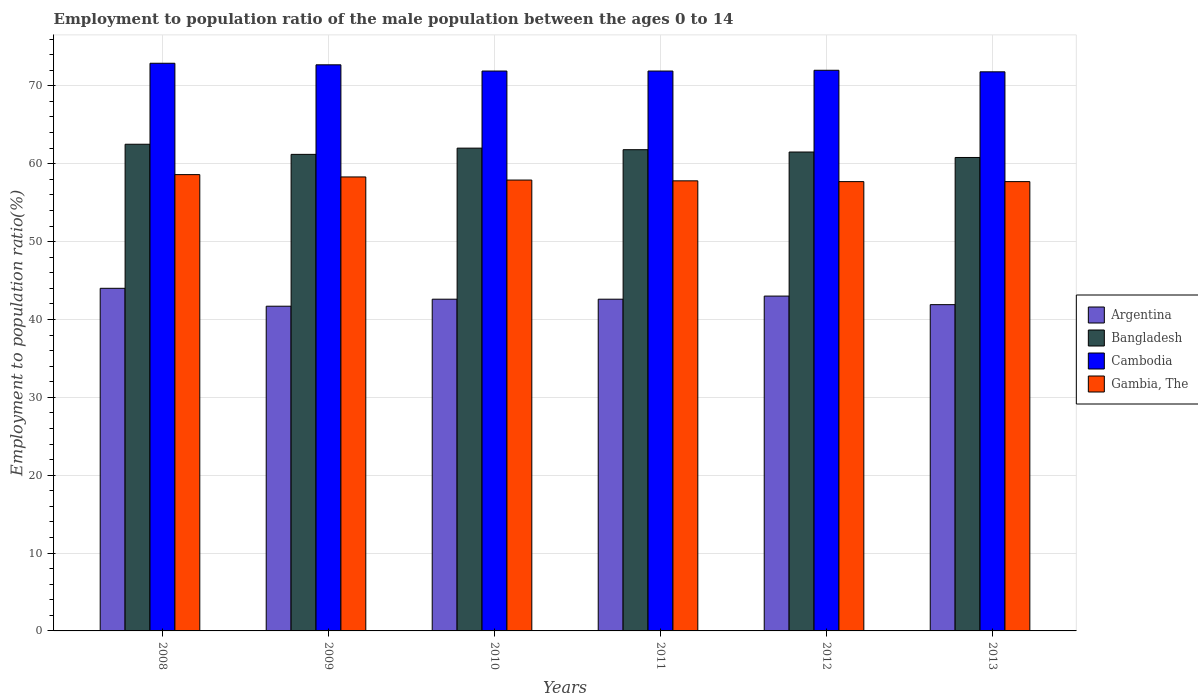How many different coloured bars are there?
Your response must be concise. 4. Are the number of bars on each tick of the X-axis equal?
Offer a terse response. Yes. What is the employment to population ratio in Gambia, The in 2012?
Your answer should be very brief. 57.7. Across all years, what is the maximum employment to population ratio in Bangladesh?
Make the answer very short. 62.5. Across all years, what is the minimum employment to population ratio in Argentina?
Keep it short and to the point. 41.7. What is the total employment to population ratio in Cambodia in the graph?
Make the answer very short. 433.2. What is the difference between the employment to population ratio in Gambia, The in 2008 and that in 2013?
Your answer should be very brief. 0.9. What is the difference between the employment to population ratio in Gambia, The in 2012 and the employment to population ratio in Cambodia in 2013?
Your answer should be very brief. -14.1. What is the average employment to population ratio in Cambodia per year?
Offer a terse response. 72.2. In the year 2011, what is the difference between the employment to population ratio in Cambodia and employment to population ratio in Argentina?
Offer a terse response. 29.3. In how many years, is the employment to population ratio in Argentina greater than 44 %?
Your answer should be very brief. 0. What is the ratio of the employment to population ratio in Bangladesh in 2009 to that in 2011?
Your answer should be compact. 0.99. Is the employment to population ratio in Bangladesh in 2008 less than that in 2012?
Keep it short and to the point. No. Is the difference between the employment to population ratio in Cambodia in 2011 and 2013 greater than the difference between the employment to population ratio in Argentina in 2011 and 2013?
Your answer should be compact. No. What is the difference between the highest and the second highest employment to population ratio in Bangladesh?
Your answer should be compact. 0.5. What is the difference between the highest and the lowest employment to population ratio in Bangladesh?
Ensure brevity in your answer.  1.7. In how many years, is the employment to population ratio in Argentina greater than the average employment to population ratio in Argentina taken over all years?
Offer a terse response. 2. Is the sum of the employment to population ratio in Bangladesh in 2010 and 2011 greater than the maximum employment to population ratio in Argentina across all years?
Give a very brief answer. Yes. What does the 4th bar from the left in 2013 represents?
Ensure brevity in your answer.  Gambia, The. What does the 2nd bar from the right in 2011 represents?
Make the answer very short. Cambodia. How many bars are there?
Ensure brevity in your answer.  24. Are all the bars in the graph horizontal?
Your answer should be compact. No. Are the values on the major ticks of Y-axis written in scientific E-notation?
Give a very brief answer. No. Does the graph contain any zero values?
Provide a succinct answer. No. Where does the legend appear in the graph?
Make the answer very short. Center right. How many legend labels are there?
Offer a terse response. 4. What is the title of the graph?
Your answer should be very brief. Employment to population ratio of the male population between the ages 0 to 14. Does "Colombia" appear as one of the legend labels in the graph?
Your answer should be compact. No. What is the label or title of the X-axis?
Your answer should be very brief. Years. What is the Employment to population ratio(%) of Bangladesh in 2008?
Make the answer very short. 62.5. What is the Employment to population ratio(%) in Cambodia in 2008?
Provide a short and direct response. 72.9. What is the Employment to population ratio(%) in Gambia, The in 2008?
Provide a short and direct response. 58.6. What is the Employment to population ratio(%) of Argentina in 2009?
Your response must be concise. 41.7. What is the Employment to population ratio(%) in Bangladesh in 2009?
Your answer should be very brief. 61.2. What is the Employment to population ratio(%) in Cambodia in 2009?
Provide a short and direct response. 72.7. What is the Employment to population ratio(%) of Gambia, The in 2009?
Your answer should be compact. 58.3. What is the Employment to population ratio(%) of Argentina in 2010?
Your answer should be compact. 42.6. What is the Employment to population ratio(%) of Cambodia in 2010?
Your answer should be very brief. 71.9. What is the Employment to population ratio(%) in Gambia, The in 2010?
Offer a terse response. 57.9. What is the Employment to population ratio(%) of Argentina in 2011?
Give a very brief answer. 42.6. What is the Employment to population ratio(%) in Bangladesh in 2011?
Your answer should be very brief. 61.8. What is the Employment to population ratio(%) of Cambodia in 2011?
Make the answer very short. 71.9. What is the Employment to population ratio(%) in Gambia, The in 2011?
Keep it short and to the point. 57.8. What is the Employment to population ratio(%) of Bangladesh in 2012?
Provide a succinct answer. 61.5. What is the Employment to population ratio(%) in Cambodia in 2012?
Give a very brief answer. 72. What is the Employment to population ratio(%) in Gambia, The in 2012?
Provide a short and direct response. 57.7. What is the Employment to population ratio(%) of Argentina in 2013?
Your answer should be very brief. 41.9. What is the Employment to population ratio(%) of Bangladesh in 2013?
Provide a succinct answer. 60.8. What is the Employment to population ratio(%) of Cambodia in 2013?
Ensure brevity in your answer.  71.8. What is the Employment to population ratio(%) of Gambia, The in 2013?
Ensure brevity in your answer.  57.7. Across all years, what is the maximum Employment to population ratio(%) in Bangladesh?
Your answer should be compact. 62.5. Across all years, what is the maximum Employment to population ratio(%) of Cambodia?
Offer a very short reply. 72.9. Across all years, what is the maximum Employment to population ratio(%) in Gambia, The?
Offer a very short reply. 58.6. Across all years, what is the minimum Employment to population ratio(%) in Argentina?
Your answer should be compact. 41.7. Across all years, what is the minimum Employment to population ratio(%) in Bangladesh?
Offer a very short reply. 60.8. Across all years, what is the minimum Employment to population ratio(%) of Cambodia?
Your answer should be compact. 71.8. Across all years, what is the minimum Employment to population ratio(%) in Gambia, The?
Your answer should be compact. 57.7. What is the total Employment to population ratio(%) in Argentina in the graph?
Provide a succinct answer. 255.8. What is the total Employment to population ratio(%) in Bangladesh in the graph?
Your answer should be compact. 369.8. What is the total Employment to population ratio(%) of Cambodia in the graph?
Provide a succinct answer. 433.2. What is the total Employment to population ratio(%) of Gambia, The in the graph?
Offer a very short reply. 348. What is the difference between the Employment to population ratio(%) of Bangladesh in 2008 and that in 2009?
Offer a terse response. 1.3. What is the difference between the Employment to population ratio(%) of Cambodia in 2008 and that in 2009?
Provide a short and direct response. 0.2. What is the difference between the Employment to population ratio(%) of Cambodia in 2008 and that in 2010?
Your answer should be very brief. 1. What is the difference between the Employment to population ratio(%) of Gambia, The in 2008 and that in 2010?
Provide a succinct answer. 0.7. What is the difference between the Employment to population ratio(%) of Cambodia in 2008 and that in 2011?
Offer a very short reply. 1. What is the difference between the Employment to population ratio(%) of Bangladesh in 2008 and that in 2012?
Keep it short and to the point. 1. What is the difference between the Employment to population ratio(%) in Cambodia in 2008 and that in 2012?
Keep it short and to the point. 0.9. What is the difference between the Employment to population ratio(%) of Gambia, The in 2008 and that in 2012?
Offer a terse response. 0.9. What is the difference between the Employment to population ratio(%) of Argentina in 2008 and that in 2013?
Your response must be concise. 2.1. What is the difference between the Employment to population ratio(%) in Bangladesh in 2008 and that in 2013?
Offer a terse response. 1.7. What is the difference between the Employment to population ratio(%) in Cambodia in 2008 and that in 2013?
Ensure brevity in your answer.  1.1. What is the difference between the Employment to population ratio(%) in Argentina in 2009 and that in 2010?
Offer a very short reply. -0.9. What is the difference between the Employment to population ratio(%) in Gambia, The in 2009 and that in 2010?
Offer a terse response. 0.4. What is the difference between the Employment to population ratio(%) in Argentina in 2009 and that in 2011?
Give a very brief answer. -0.9. What is the difference between the Employment to population ratio(%) of Gambia, The in 2009 and that in 2011?
Make the answer very short. 0.5. What is the difference between the Employment to population ratio(%) of Cambodia in 2009 and that in 2012?
Offer a terse response. 0.7. What is the difference between the Employment to population ratio(%) of Argentina in 2010 and that in 2011?
Keep it short and to the point. 0. What is the difference between the Employment to population ratio(%) in Bangladesh in 2010 and that in 2011?
Ensure brevity in your answer.  0.2. What is the difference between the Employment to population ratio(%) of Cambodia in 2010 and that in 2011?
Provide a short and direct response. 0. What is the difference between the Employment to population ratio(%) of Argentina in 2010 and that in 2012?
Offer a very short reply. -0.4. What is the difference between the Employment to population ratio(%) of Gambia, The in 2010 and that in 2012?
Your answer should be very brief. 0.2. What is the difference between the Employment to population ratio(%) in Argentina in 2010 and that in 2013?
Make the answer very short. 0.7. What is the difference between the Employment to population ratio(%) in Bangladesh in 2010 and that in 2013?
Ensure brevity in your answer.  1.2. What is the difference between the Employment to population ratio(%) of Cambodia in 2010 and that in 2013?
Offer a terse response. 0.1. What is the difference between the Employment to population ratio(%) in Cambodia in 2011 and that in 2012?
Keep it short and to the point. -0.1. What is the difference between the Employment to population ratio(%) in Argentina in 2011 and that in 2013?
Make the answer very short. 0.7. What is the difference between the Employment to population ratio(%) in Argentina in 2012 and that in 2013?
Keep it short and to the point. 1.1. What is the difference between the Employment to population ratio(%) of Bangladesh in 2012 and that in 2013?
Provide a short and direct response. 0.7. What is the difference between the Employment to population ratio(%) of Gambia, The in 2012 and that in 2013?
Give a very brief answer. 0. What is the difference between the Employment to population ratio(%) of Argentina in 2008 and the Employment to population ratio(%) of Bangladesh in 2009?
Give a very brief answer. -17.2. What is the difference between the Employment to population ratio(%) in Argentina in 2008 and the Employment to population ratio(%) in Cambodia in 2009?
Your response must be concise. -28.7. What is the difference between the Employment to population ratio(%) in Argentina in 2008 and the Employment to population ratio(%) in Gambia, The in 2009?
Provide a succinct answer. -14.3. What is the difference between the Employment to population ratio(%) in Bangladesh in 2008 and the Employment to population ratio(%) in Cambodia in 2009?
Ensure brevity in your answer.  -10.2. What is the difference between the Employment to population ratio(%) of Bangladesh in 2008 and the Employment to population ratio(%) of Gambia, The in 2009?
Make the answer very short. 4.2. What is the difference between the Employment to population ratio(%) in Argentina in 2008 and the Employment to population ratio(%) in Cambodia in 2010?
Your answer should be compact. -27.9. What is the difference between the Employment to population ratio(%) of Argentina in 2008 and the Employment to population ratio(%) of Gambia, The in 2010?
Your answer should be very brief. -13.9. What is the difference between the Employment to population ratio(%) in Bangladesh in 2008 and the Employment to population ratio(%) in Cambodia in 2010?
Provide a short and direct response. -9.4. What is the difference between the Employment to population ratio(%) in Argentina in 2008 and the Employment to population ratio(%) in Bangladesh in 2011?
Offer a very short reply. -17.8. What is the difference between the Employment to population ratio(%) of Argentina in 2008 and the Employment to population ratio(%) of Cambodia in 2011?
Offer a very short reply. -27.9. What is the difference between the Employment to population ratio(%) of Argentina in 2008 and the Employment to population ratio(%) of Gambia, The in 2011?
Ensure brevity in your answer.  -13.8. What is the difference between the Employment to population ratio(%) in Bangladesh in 2008 and the Employment to population ratio(%) in Gambia, The in 2011?
Your answer should be compact. 4.7. What is the difference between the Employment to population ratio(%) of Cambodia in 2008 and the Employment to population ratio(%) of Gambia, The in 2011?
Your answer should be compact. 15.1. What is the difference between the Employment to population ratio(%) of Argentina in 2008 and the Employment to population ratio(%) of Bangladesh in 2012?
Offer a very short reply. -17.5. What is the difference between the Employment to population ratio(%) of Argentina in 2008 and the Employment to population ratio(%) of Cambodia in 2012?
Provide a succinct answer. -28. What is the difference between the Employment to population ratio(%) in Argentina in 2008 and the Employment to population ratio(%) in Gambia, The in 2012?
Your answer should be very brief. -13.7. What is the difference between the Employment to population ratio(%) in Bangladesh in 2008 and the Employment to population ratio(%) in Cambodia in 2012?
Your response must be concise. -9.5. What is the difference between the Employment to population ratio(%) in Bangladesh in 2008 and the Employment to population ratio(%) in Gambia, The in 2012?
Offer a terse response. 4.8. What is the difference between the Employment to population ratio(%) of Argentina in 2008 and the Employment to population ratio(%) of Bangladesh in 2013?
Ensure brevity in your answer.  -16.8. What is the difference between the Employment to population ratio(%) of Argentina in 2008 and the Employment to population ratio(%) of Cambodia in 2013?
Offer a terse response. -27.8. What is the difference between the Employment to population ratio(%) in Argentina in 2008 and the Employment to population ratio(%) in Gambia, The in 2013?
Provide a succinct answer. -13.7. What is the difference between the Employment to population ratio(%) of Bangladesh in 2008 and the Employment to population ratio(%) of Cambodia in 2013?
Give a very brief answer. -9.3. What is the difference between the Employment to population ratio(%) of Bangladesh in 2008 and the Employment to population ratio(%) of Gambia, The in 2013?
Your answer should be compact. 4.8. What is the difference between the Employment to population ratio(%) of Argentina in 2009 and the Employment to population ratio(%) of Bangladesh in 2010?
Your answer should be very brief. -20.3. What is the difference between the Employment to population ratio(%) of Argentina in 2009 and the Employment to population ratio(%) of Cambodia in 2010?
Provide a short and direct response. -30.2. What is the difference between the Employment to population ratio(%) of Argentina in 2009 and the Employment to population ratio(%) of Gambia, The in 2010?
Keep it short and to the point. -16.2. What is the difference between the Employment to population ratio(%) of Bangladesh in 2009 and the Employment to population ratio(%) of Gambia, The in 2010?
Your response must be concise. 3.3. What is the difference between the Employment to population ratio(%) of Cambodia in 2009 and the Employment to population ratio(%) of Gambia, The in 2010?
Provide a short and direct response. 14.8. What is the difference between the Employment to population ratio(%) in Argentina in 2009 and the Employment to population ratio(%) in Bangladesh in 2011?
Provide a short and direct response. -20.1. What is the difference between the Employment to population ratio(%) of Argentina in 2009 and the Employment to population ratio(%) of Cambodia in 2011?
Your response must be concise. -30.2. What is the difference between the Employment to population ratio(%) of Argentina in 2009 and the Employment to population ratio(%) of Gambia, The in 2011?
Offer a very short reply. -16.1. What is the difference between the Employment to population ratio(%) in Bangladesh in 2009 and the Employment to population ratio(%) in Cambodia in 2011?
Your response must be concise. -10.7. What is the difference between the Employment to population ratio(%) of Cambodia in 2009 and the Employment to population ratio(%) of Gambia, The in 2011?
Give a very brief answer. 14.9. What is the difference between the Employment to population ratio(%) in Argentina in 2009 and the Employment to population ratio(%) in Bangladesh in 2012?
Your answer should be very brief. -19.8. What is the difference between the Employment to population ratio(%) in Argentina in 2009 and the Employment to population ratio(%) in Cambodia in 2012?
Ensure brevity in your answer.  -30.3. What is the difference between the Employment to population ratio(%) of Argentina in 2009 and the Employment to population ratio(%) of Gambia, The in 2012?
Your answer should be compact. -16. What is the difference between the Employment to population ratio(%) of Bangladesh in 2009 and the Employment to population ratio(%) of Cambodia in 2012?
Your answer should be very brief. -10.8. What is the difference between the Employment to population ratio(%) in Argentina in 2009 and the Employment to population ratio(%) in Bangladesh in 2013?
Make the answer very short. -19.1. What is the difference between the Employment to population ratio(%) of Argentina in 2009 and the Employment to population ratio(%) of Cambodia in 2013?
Your answer should be compact. -30.1. What is the difference between the Employment to population ratio(%) in Bangladesh in 2009 and the Employment to population ratio(%) in Cambodia in 2013?
Your response must be concise. -10.6. What is the difference between the Employment to population ratio(%) of Bangladesh in 2009 and the Employment to population ratio(%) of Gambia, The in 2013?
Give a very brief answer. 3.5. What is the difference between the Employment to population ratio(%) in Cambodia in 2009 and the Employment to population ratio(%) in Gambia, The in 2013?
Provide a short and direct response. 15. What is the difference between the Employment to population ratio(%) in Argentina in 2010 and the Employment to population ratio(%) in Bangladesh in 2011?
Give a very brief answer. -19.2. What is the difference between the Employment to population ratio(%) of Argentina in 2010 and the Employment to population ratio(%) of Cambodia in 2011?
Provide a succinct answer. -29.3. What is the difference between the Employment to population ratio(%) in Argentina in 2010 and the Employment to population ratio(%) in Gambia, The in 2011?
Offer a very short reply. -15.2. What is the difference between the Employment to population ratio(%) in Bangladesh in 2010 and the Employment to population ratio(%) in Gambia, The in 2011?
Make the answer very short. 4.2. What is the difference between the Employment to population ratio(%) of Argentina in 2010 and the Employment to population ratio(%) of Bangladesh in 2012?
Provide a short and direct response. -18.9. What is the difference between the Employment to population ratio(%) of Argentina in 2010 and the Employment to population ratio(%) of Cambodia in 2012?
Provide a succinct answer. -29.4. What is the difference between the Employment to population ratio(%) in Argentina in 2010 and the Employment to population ratio(%) in Gambia, The in 2012?
Offer a very short reply. -15.1. What is the difference between the Employment to population ratio(%) in Bangladesh in 2010 and the Employment to population ratio(%) in Cambodia in 2012?
Offer a very short reply. -10. What is the difference between the Employment to population ratio(%) in Cambodia in 2010 and the Employment to population ratio(%) in Gambia, The in 2012?
Provide a succinct answer. 14.2. What is the difference between the Employment to population ratio(%) in Argentina in 2010 and the Employment to population ratio(%) in Bangladesh in 2013?
Provide a succinct answer. -18.2. What is the difference between the Employment to population ratio(%) in Argentina in 2010 and the Employment to population ratio(%) in Cambodia in 2013?
Ensure brevity in your answer.  -29.2. What is the difference between the Employment to population ratio(%) in Argentina in 2010 and the Employment to population ratio(%) in Gambia, The in 2013?
Your response must be concise. -15.1. What is the difference between the Employment to population ratio(%) of Bangladesh in 2010 and the Employment to population ratio(%) of Gambia, The in 2013?
Make the answer very short. 4.3. What is the difference between the Employment to population ratio(%) in Argentina in 2011 and the Employment to population ratio(%) in Bangladesh in 2012?
Provide a short and direct response. -18.9. What is the difference between the Employment to population ratio(%) of Argentina in 2011 and the Employment to population ratio(%) of Cambodia in 2012?
Your answer should be compact. -29.4. What is the difference between the Employment to population ratio(%) in Argentina in 2011 and the Employment to population ratio(%) in Gambia, The in 2012?
Provide a short and direct response. -15.1. What is the difference between the Employment to population ratio(%) in Bangladesh in 2011 and the Employment to population ratio(%) in Cambodia in 2012?
Offer a terse response. -10.2. What is the difference between the Employment to population ratio(%) in Argentina in 2011 and the Employment to population ratio(%) in Bangladesh in 2013?
Provide a short and direct response. -18.2. What is the difference between the Employment to population ratio(%) in Argentina in 2011 and the Employment to population ratio(%) in Cambodia in 2013?
Make the answer very short. -29.2. What is the difference between the Employment to population ratio(%) of Argentina in 2011 and the Employment to population ratio(%) of Gambia, The in 2013?
Make the answer very short. -15.1. What is the difference between the Employment to population ratio(%) in Cambodia in 2011 and the Employment to population ratio(%) in Gambia, The in 2013?
Ensure brevity in your answer.  14.2. What is the difference between the Employment to population ratio(%) of Argentina in 2012 and the Employment to population ratio(%) of Bangladesh in 2013?
Keep it short and to the point. -17.8. What is the difference between the Employment to population ratio(%) of Argentina in 2012 and the Employment to population ratio(%) of Cambodia in 2013?
Ensure brevity in your answer.  -28.8. What is the difference between the Employment to population ratio(%) in Argentina in 2012 and the Employment to population ratio(%) in Gambia, The in 2013?
Your answer should be very brief. -14.7. What is the difference between the Employment to population ratio(%) in Bangladesh in 2012 and the Employment to population ratio(%) in Gambia, The in 2013?
Offer a terse response. 3.8. What is the average Employment to population ratio(%) in Argentina per year?
Offer a terse response. 42.63. What is the average Employment to population ratio(%) in Bangladesh per year?
Offer a very short reply. 61.63. What is the average Employment to population ratio(%) of Cambodia per year?
Offer a very short reply. 72.2. In the year 2008, what is the difference between the Employment to population ratio(%) of Argentina and Employment to population ratio(%) of Bangladesh?
Ensure brevity in your answer.  -18.5. In the year 2008, what is the difference between the Employment to population ratio(%) of Argentina and Employment to population ratio(%) of Cambodia?
Offer a terse response. -28.9. In the year 2008, what is the difference between the Employment to population ratio(%) in Argentina and Employment to population ratio(%) in Gambia, The?
Your response must be concise. -14.6. In the year 2008, what is the difference between the Employment to population ratio(%) of Cambodia and Employment to population ratio(%) of Gambia, The?
Offer a very short reply. 14.3. In the year 2009, what is the difference between the Employment to population ratio(%) of Argentina and Employment to population ratio(%) of Bangladesh?
Ensure brevity in your answer.  -19.5. In the year 2009, what is the difference between the Employment to population ratio(%) in Argentina and Employment to population ratio(%) in Cambodia?
Your answer should be compact. -31. In the year 2009, what is the difference between the Employment to population ratio(%) of Argentina and Employment to population ratio(%) of Gambia, The?
Make the answer very short. -16.6. In the year 2009, what is the difference between the Employment to population ratio(%) in Bangladesh and Employment to population ratio(%) in Cambodia?
Provide a short and direct response. -11.5. In the year 2009, what is the difference between the Employment to population ratio(%) of Bangladesh and Employment to population ratio(%) of Gambia, The?
Provide a short and direct response. 2.9. In the year 2010, what is the difference between the Employment to population ratio(%) in Argentina and Employment to population ratio(%) in Bangladesh?
Your answer should be very brief. -19.4. In the year 2010, what is the difference between the Employment to population ratio(%) in Argentina and Employment to population ratio(%) in Cambodia?
Provide a succinct answer. -29.3. In the year 2010, what is the difference between the Employment to population ratio(%) in Argentina and Employment to population ratio(%) in Gambia, The?
Your answer should be compact. -15.3. In the year 2011, what is the difference between the Employment to population ratio(%) of Argentina and Employment to population ratio(%) of Bangladesh?
Give a very brief answer. -19.2. In the year 2011, what is the difference between the Employment to population ratio(%) in Argentina and Employment to population ratio(%) in Cambodia?
Keep it short and to the point. -29.3. In the year 2011, what is the difference between the Employment to population ratio(%) of Argentina and Employment to population ratio(%) of Gambia, The?
Keep it short and to the point. -15.2. In the year 2011, what is the difference between the Employment to population ratio(%) in Bangladesh and Employment to population ratio(%) in Cambodia?
Offer a very short reply. -10.1. In the year 2011, what is the difference between the Employment to population ratio(%) of Bangladesh and Employment to population ratio(%) of Gambia, The?
Offer a terse response. 4. In the year 2012, what is the difference between the Employment to population ratio(%) of Argentina and Employment to population ratio(%) of Bangladesh?
Give a very brief answer. -18.5. In the year 2012, what is the difference between the Employment to population ratio(%) of Argentina and Employment to population ratio(%) of Cambodia?
Your answer should be compact. -29. In the year 2012, what is the difference between the Employment to population ratio(%) of Argentina and Employment to population ratio(%) of Gambia, The?
Your answer should be very brief. -14.7. In the year 2013, what is the difference between the Employment to population ratio(%) of Argentina and Employment to population ratio(%) of Bangladesh?
Keep it short and to the point. -18.9. In the year 2013, what is the difference between the Employment to population ratio(%) in Argentina and Employment to population ratio(%) in Cambodia?
Your answer should be compact. -29.9. In the year 2013, what is the difference between the Employment to population ratio(%) of Argentina and Employment to population ratio(%) of Gambia, The?
Provide a succinct answer. -15.8. In the year 2013, what is the difference between the Employment to population ratio(%) in Bangladesh and Employment to population ratio(%) in Cambodia?
Keep it short and to the point. -11. In the year 2013, what is the difference between the Employment to population ratio(%) of Bangladesh and Employment to population ratio(%) of Gambia, The?
Offer a terse response. 3.1. What is the ratio of the Employment to population ratio(%) of Argentina in 2008 to that in 2009?
Keep it short and to the point. 1.06. What is the ratio of the Employment to population ratio(%) in Bangladesh in 2008 to that in 2009?
Provide a short and direct response. 1.02. What is the ratio of the Employment to population ratio(%) in Cambodia in 2008 to that in 2009?
Give a very brief answer. 1. What is the ratio of the Employment to population ratio(%) in Gambia, The in 2008 to that in 2009?
Your answer should be very brief. 1.01. What is the ratio of the Employment to population ratio(%) of Argentina in 2008 to that in 2010?
Offer a very short reply. 1.03. What is the ratio of the Employment to population ratio(%) in Bangladesh in 2008 to that in 2010?
Offer a terse response. 1.01. What is the ratio of the Employment to population ratio(%) in Cambodia in 2008 to that in 2010?
Your answer should be very brief. 1.01. What is the ratio of the Employment to population ratio(%) in Gambia, The in 2008 to that in 2010?
Make the answer very short. 1.01. What is the ratio of the Employment to population ratio(%) of Argentina in 2008 to that in 2011?
Your answer should be very brief. 1.03. What is the ratio of the Employment to population ratio(%) in Bangladesh in 2008 to that in 2011?
Offer a terse response. 1.01. What is the ratio of the Employment to population ratio(%) in Cambodia in 2008 to that in 2011?
Keep it short and to the point. 1.01. What is the ratio of the Employment to population ratio(%) of Gambia, The in 2008 to that in 2011?
Give a very brief answer. 1.01. What is the ratio of the Employment to population ratio(%) of Argentina in 2008 to that in 2012?
Your answer should be compact. 1.02. What is the ratio of the Employment to population ratio(%) in Bangladesh in 2008 to that in 2012?
Your response must be concise. 1.02. What is the ratio of the Employment to population ratio(%) in Cambodia in 2008 to that in 2012?
Provide a succinct answer. 1.01. What is the ratio of the Employment to population ratio(%) of Gambia, The in 2008 to that in 2012?
Keep it short and to the point. 1.02. What is the ratio of the Employment to population ratio(%) of Argentina in 2008 to that in 2013?
Ensure brevity in your answer.  1.05. What is the ratio of the Employment to population ratio(%) of Bangladesh in 2008 to that in 2013?
Give a very brief answer. 1.03. What is the ratio of the Employment to population ratio(%) of Cambodia in 2008 to that in 2013?
Give a very brief answer. 1.02. What is the ratio of the Employment to population ratio(%) in Gambia, The in 2008 to that in 2013?
Make the answer very short. 1.02. What is the ratio of the Employment to population ratio(%) in Argentina in 2009 to that in 2010?
Offer a very short reply. 0.98. What is the ratio of the Employment to population ratio(%) in Bangladesh in 2009 to that in 2010?
Your answer should be compact. 0.99. What is the ratio of the Employment to population ratio(%) in Cambodia in 2009 to that in 2010?
Provide a short and direct response. 1.01. What is the ratio of the Employment to population ratio(%) in Gambia, The in 2009 to that in 2010?
Your answer should be compact. 1.01. What is the ratio of the Employment to population ratio(%) in Argentina in 2009 to that in 2011?
Provide a succinct answer. 0.98. What is the ratio of the Employment to population ratio(%) of Bangladesh in 2009 to that in 2011?
Your response must be concise. 0.99. What is the ratio of the Employment to population ratio(%) of Cambodia in 2009 to that in 2011?
Your answer should be very brief. 1.01. What is the ratio of the Employment to population ratio(%) in Gambia, The in 2009 to that in 2011?
Your answer should be compact. 1.01. What is the ratio of the Employment to population ratio(%) of Argentina in 2009 to that in 2012?
Your answer should be compact. 0.97. What is the ratio of the Employment to population ratio(%) in Bangladesh in 2009 to that in 2012?
Keep it short and to the point. 1. What is the ratio of the Employment to population ratio(%) of Cambodia in 2009 to that in 2012?
Make the answer very short. 1.01. What is the ratio of the Employment to population ratio(%) of Gambia, The in 2009 to that in 2012?
Your response must be concise. 1.01. What is the ratio of the Employment to population ratio(%) of Bangladesh in 2009 to that in 2013?
Make the answer very short. 1.01. What is the ratio of the Employment to population ratio(%) in Cambodia in 2009 to that in 2013?
Keep it short and to the point. 1.01. What is the ratio of the Employment to population ratio(%) of Gambia, The in 2009 to that in 2013?
Provide a succinct answer. 1.01. What is the ratio of the Employment to population ratio(%) of Argentina in 2010 to that in 2011?
Offer a terse response. 1. What is the ratio of the Employment to population ratio(%) of Bangladesh in 2010 to that in 2011?
Your answer should be compact. 1. What is the ratio of the Employment to population ratio(%) of Cambodia in 2010 to that in 2011?
Make the answer very short. 1. What is the ratio of the Employment to population ratio(%) of Bangladesh in 2010 to that in 2012?
Offer a very short reply. 1.01. What is the ratio of the Employment to population ratio(%) in Cambodia in 2010 to that in 2012?
Make the answer very short. 1. What is the ratio of the Employment to population ratio(%) of Argentina in 2010 to that in 2013?
Provide a succinct answer. 1.02. What is the ratio of the Employment to population ratio(%) in Bangladesh in 2010 to that in 2013?
Provide a succinct answer. 1.02. What is the ratio of the Employment to population ratio(%) of Cambodia in 2010 to that in 2013?
Your response must be concise. 1. What is the ratio of the Employment to population ratio(%) of Gambia, The in 2010 to that in 2013?
Give a very brief answer. 1. What is the ratio of the Employment to population ratio(%) in Argentina in 2011 to that in 2012?
Your response must be concise. 0.99. What is the ratio of the Employment to population ratio(%) of Bangladesh in 2011 to that in 2012?
Your response must be concise. 1. What is the ratio of the Employment to population ratio(%) of Argentina in 2011 to that in 2013?
Ensure brevity in your answer.  1.02. What is the ratio of the Employment to population ratio(%) of Bangladesh in 2011 to that in 2013?
Offer a terse response. 1.02. What is the ratio of the Employment to population ratio(%) of Cambodia in 2011 to that in 2013?
Ensure brevity in your answer.  1. What is the ratio of the Employment to population ratio(%) in Gambia, The in 2011 to that in 2013?
Provide a short and direct response. 1. What is the ratio of the Employment to population ratio(%) of Argentina in 2012 to that in 2013?
Provide a succinct answer. 1.03. What is the ratio of the Employment to population ratio(%) in Bangladesh in 2012 to that in 2013?
Ensure brevity in your answer.  1.01. What is the ratio of the Employment to population ratio(%) in Cambodia in 2012 to that in 2013?
Make the answer very short. 1. What is the difference between the highest and the second highest Employment to population ratio(%) of Argentina?
Your response must be concise. 1. What is the difference between the highest and the second highest Employment to population ratio(%) in Bangladesh?
Keep it short and to the point. 0.5. What is the difference between the highest and the second highest Employment to population ratio(%) of Cambodia?
Ensure brevity in your answer.  0.2. What is the difference between the highest and the second highest Employment to population ratio(%) of Gambia, The?
Keep it short and to the point. 0.3. What is the difference between the highest and the lowest Employment to population ratio(%) of Cambodia?
Make the answer very short. 1.1. What is the difference between the highest and the lowest Employment to population ratio(%) of Gambia, The?
Your answer should be compact. 0.9. 